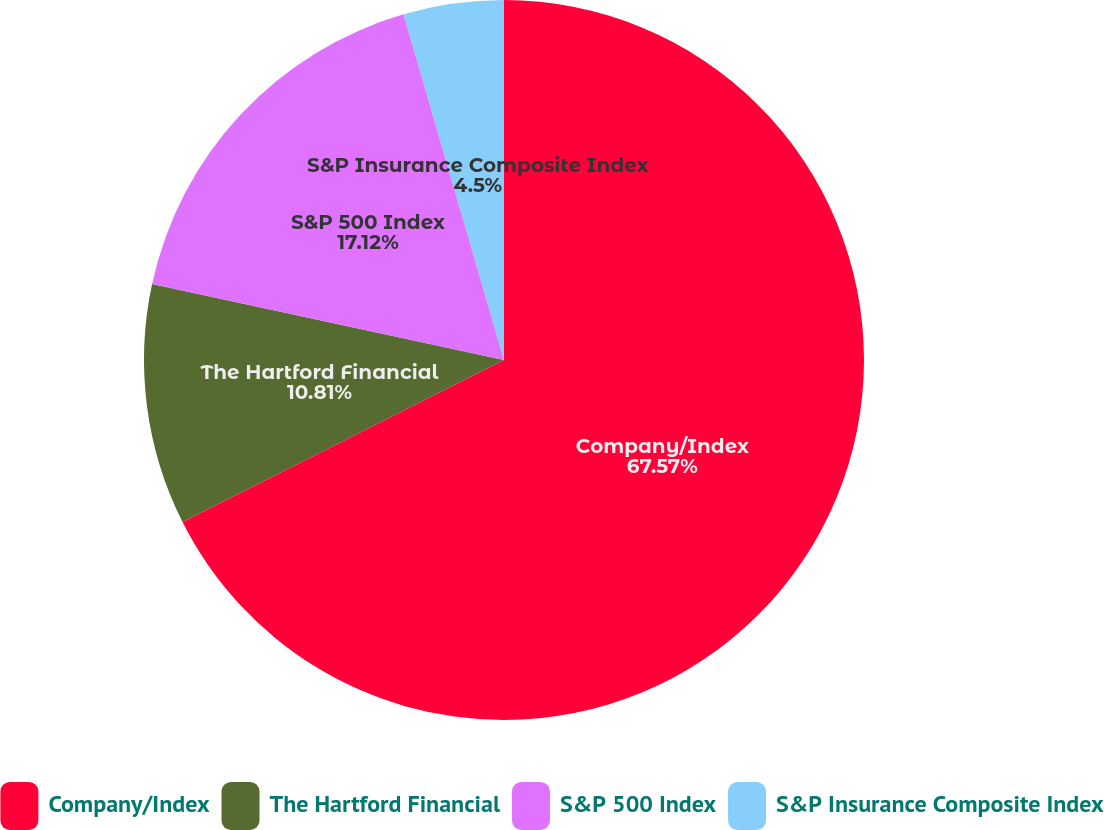Convert chart to OTSL. <chart><loc_0><loc_0><loc_500><loc_500><pie_chart><fcel>Company/Index<fcel>The Hartford Financial<fcel>S&P 500 Index<fcel>S&P Insurance Composite Index<nl><fcel>67.57%<fcel>10.81%<fcel>17.12%<fcel>4.5%<nl></chart> 